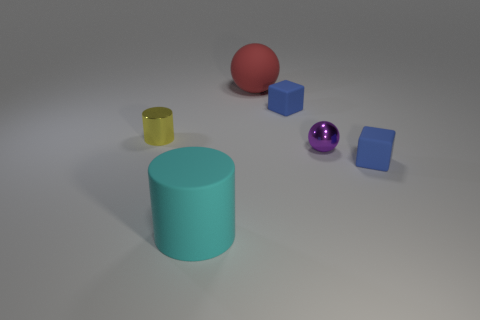What is the color of the cylinder that is in front of the shiny ball?
Your answer should be compact. Cyan. There is a blue cube that is in front of the small blue block that is behind the tiny thing left of the big cyan cylinder; what is its material?
Your answer should be very brief. Rubber. Is there a blue thing of the same shape as the cyan matte thing?
Your answer should be very brief. No. What is the shape of the cyan object that is the same size as the red ball?
Your answer should be compact. Cylinder. What number of objects are left of the purple metallic thing and on the right side of the tiny yellow cylinder?
Provide a succinct answer. 3. Are there fewer rubber cylinders on the right side of the purple shiny sphere than tiny blue objects?
Your response must be concise. Yes. Is there a purple block of the same size as the cyan matte cylinder?
Offer a terse response. No. The small cylinder that is the same material as the small purple thing is what color?
Offer a terse response. Yellow. There is a red matte object that is behind the small metallic cylinder; how many tiny purple objects are in front of it?
Make the answer very short. 1. What is the thing that is both behind the tiny metallic cylinder and in front of the big ball made of?
Offer a terse response. Rubber. 